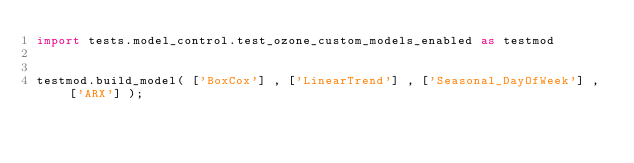<code> <loc_0><loc_0><loc_500><loc_500><_Python_>import tests.model_control.test_ozone_custom_models_enabled as testmod


testmod.build_model( ['BoxCox'] , ['LinearTrend'] , ['Seasonal_DayOfWeek'] , ['ARX'] );</code> 